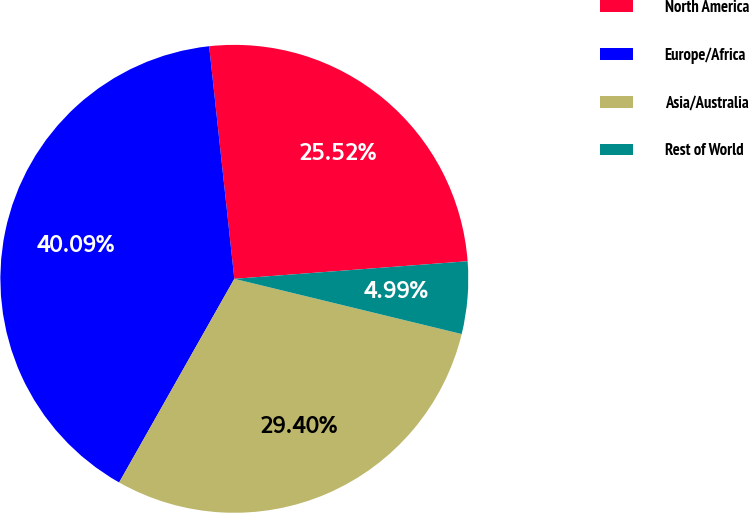<chart> <loc_0><loc_0><loc_500><loc_500><pie_chart><fcel>North America<fcel>Europe/Africa<fcel>Asia/Australia<fcel>Rest of World<nl><fcel>25.52%<fcel>40.09%<fcel>29.4%<fcel>4.99%<nl></chart> 